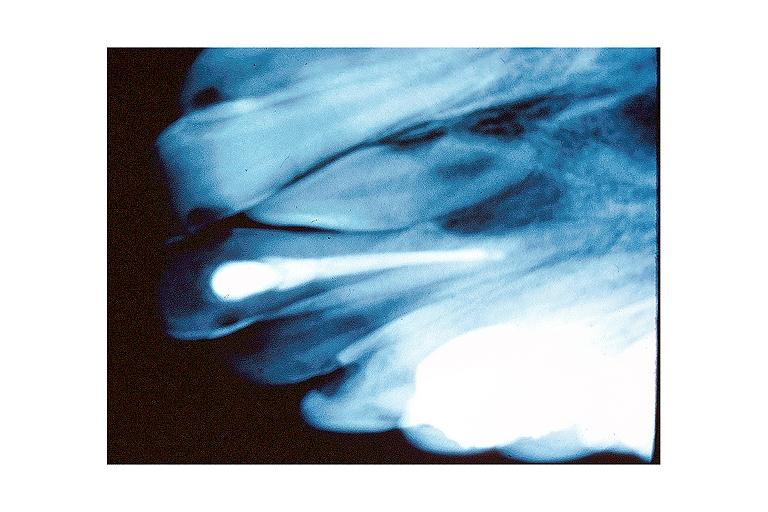where is this?
Answer the question using a single word or phrase. Oral 